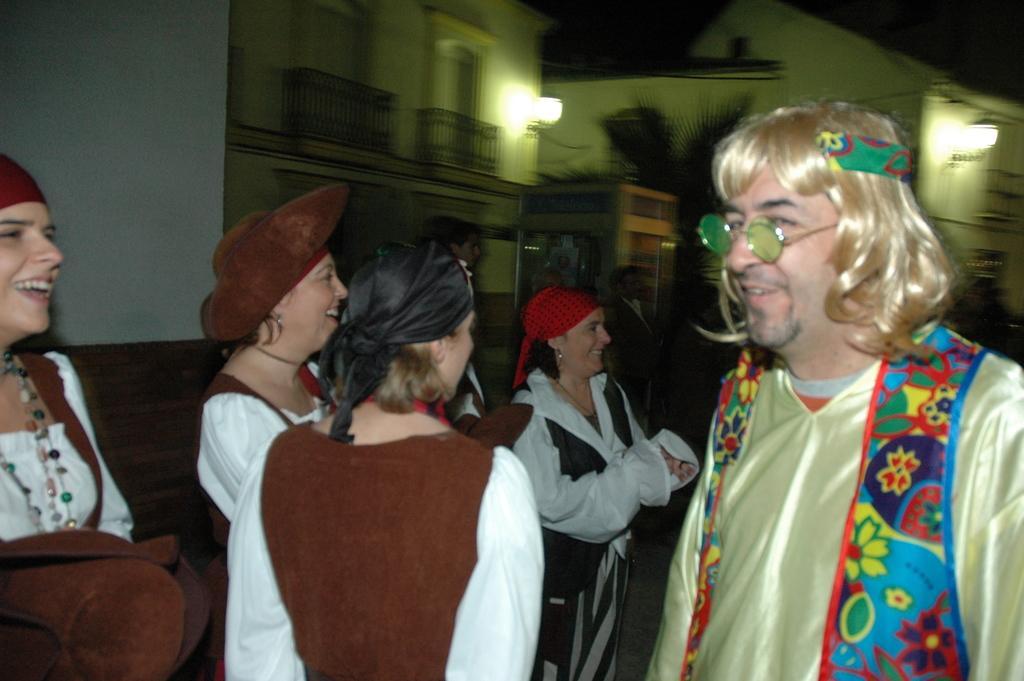Could you give a brief overview of what you see in this image? In the image we can see there are people wearing clothes and some of them are wearing the cap, they are smiling. Here we can see buildings, fence, plant, lights and the dark sky. 